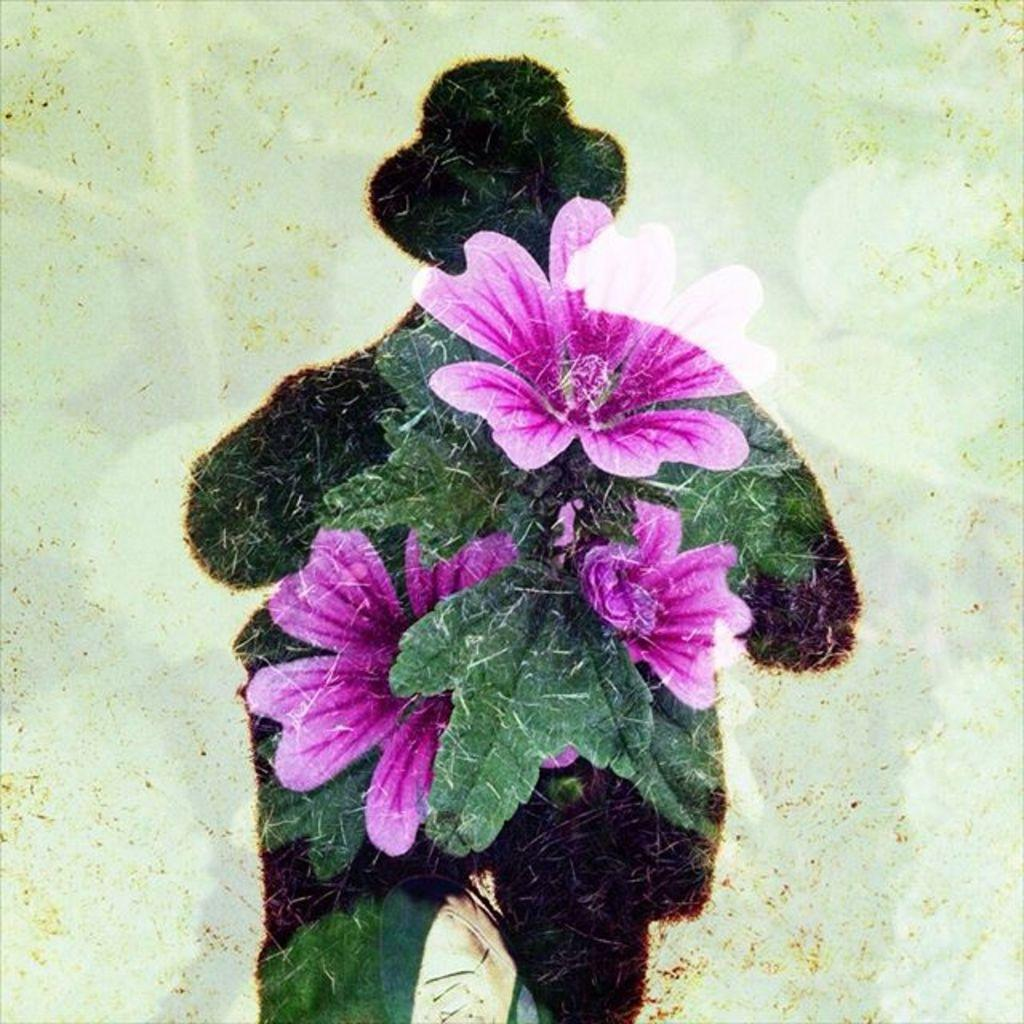What type of living organisms can be seen in the image? There are flowers in the image. Can you describe the shape of the person visible in the image? The shape of a person is visible in the image. What type of meat can be seen hanging from the flowers in the image? There is no meat present in the image; it features flowers and the shape of a person. Can you describe the mist surrounding the person in the image? There is no mist present in the image; it only features flowers and the shape of a person. 